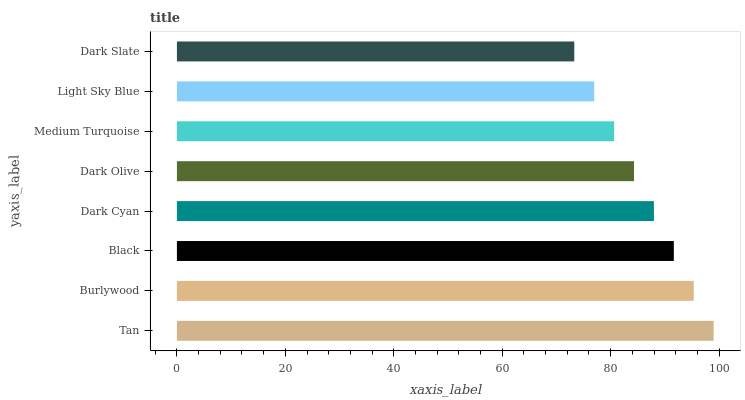Is Dark Slate the minimum?
Answer yes or no. Yes. Is Tan the maximum?
Answer yes or no. Yes. Is Burlywood the minimum?
Answer yes or no. No. Is Burlywood the maximum?
Answer yes or no. No. Is Tan greater than Burlywood?
Answer yes or no. Yes. Is Burlywood less than Tan?
Answer yes or no. Yes. Is Burlywood greater than Tan?
Answer yes or no. No. Is Tan less than Burlywood?
Answer yes or no. No. Is Dark Cyan the high median?
Answer yes or no. Yes. Is Dark Olive the low median?
Answer yes or no. Yes. Is Tan the high median?
Answer yes or no. No. Is Medium Turquoise the low median?
Answer yes or no. No. 